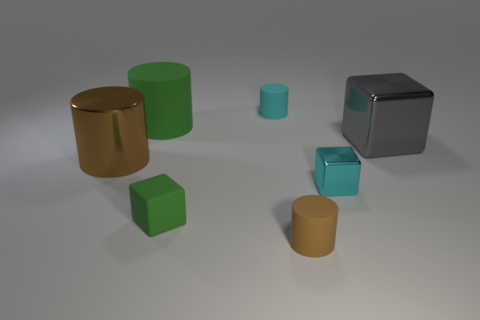Subtract all metallic blocks. How many blocks are left? 1 Subtract all brown cylinders. How many cylinders are left? 2 Subtract all blocks. How many objects are left? 4 Subtract 1 cylinders. How many cylinders are left? 3 Subtract all red cylinders. Subtract all brown blocks. How many cylinders are left? 4 Subtract all purple balls. How many blue cylinders are left? 0 Subtract all brown cylinders. Subtract all tiny blue metallic cylinders. How many objects are left? 5 Add 5 big gray cubes. How many big gray cubes are left? 6 Add 3 green rubber objects. How many green rubber objects exist? 5 Add 1 cubes. How many objects exist? 8 